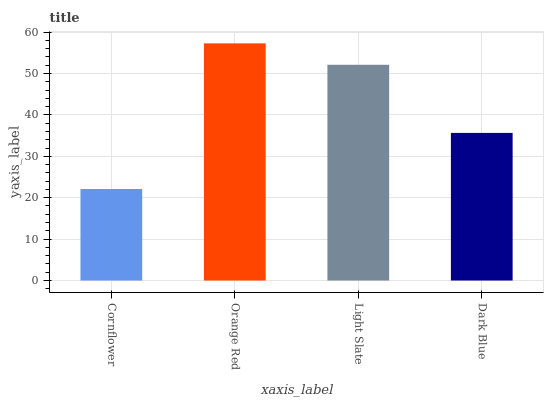Is Cornflower the minimum?
Answer yes or no. Yes. Is Orange Red the maximum?
Answer yes or no. Yes. Is Light Slate the minimum?
Answer yes or no. No. Is Light Slate the maximum?
Answer yes or no. No. Is Orange Red greater than Light Slate?
Answer yes or no. Yes. Is Light Slate less than Orange Red?
Answer yes or no. Yes. Is Light Slate greater than Orange Red?
Answer yes or no. No. Is Orange Red less than Light Slate?
Answer yes or no. No. Is Light Slate the high median?
Answer yes or no. Yes. Is Dark Blue the low median?
Answer yes or no. Yes. Is Dark Blue the high median?
Answer yes or no. No. Is Cornflower the low median?
Answer yes or no. No. 